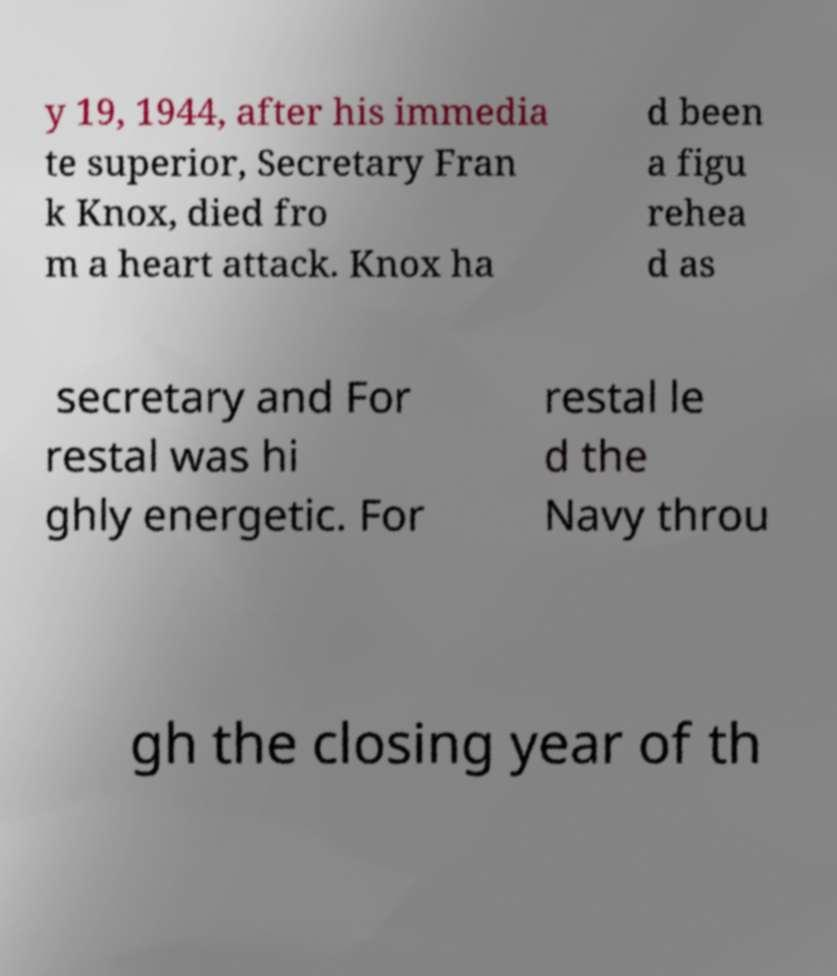For documentation purposes, I need the text within this image transcribed. Could you provide that? y 19, 1944, after his immedia te superior, Secretary Fran k Knox, died fro m a heart attack. Knox ha d been a figu rehea d as secretary and For restal was hi ghly energetic. For restal le d the Navy throu gh the closing year of th 